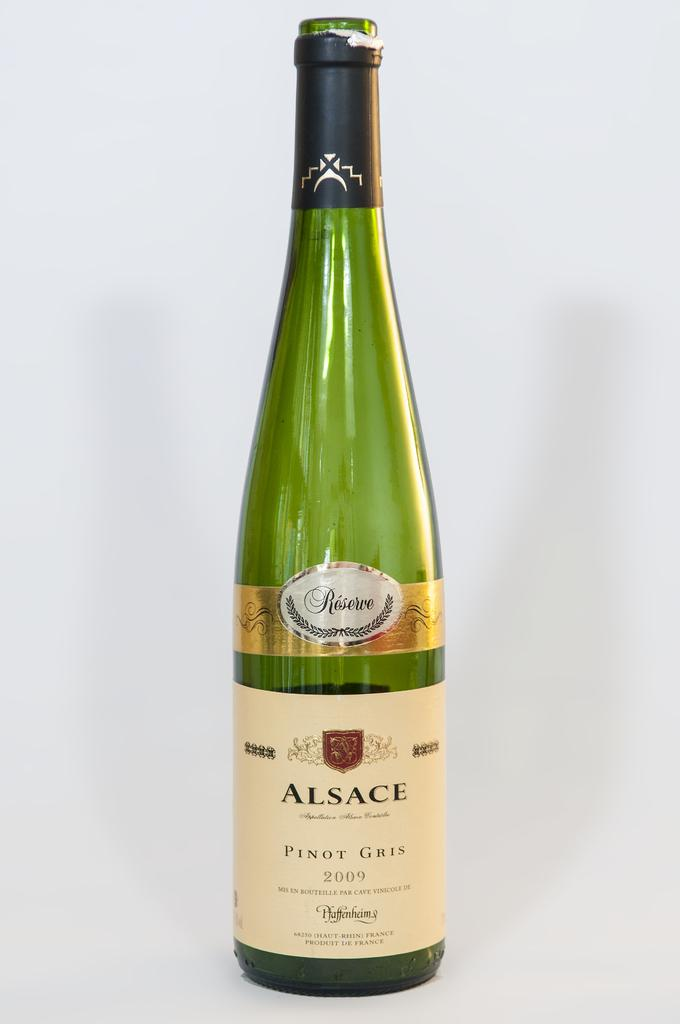<image>
Share a concise interpretation of the image provided. green bottle of 2009 alsace pinot gris reserve 